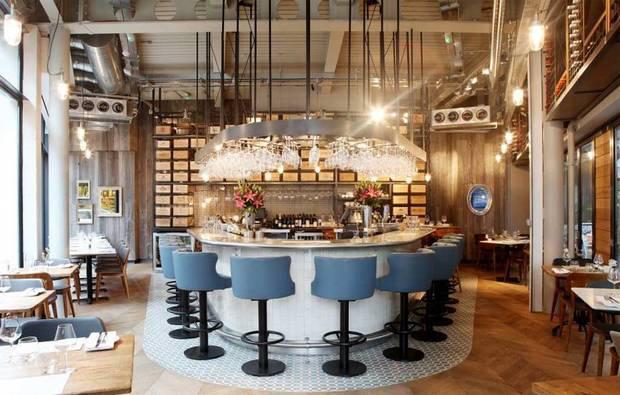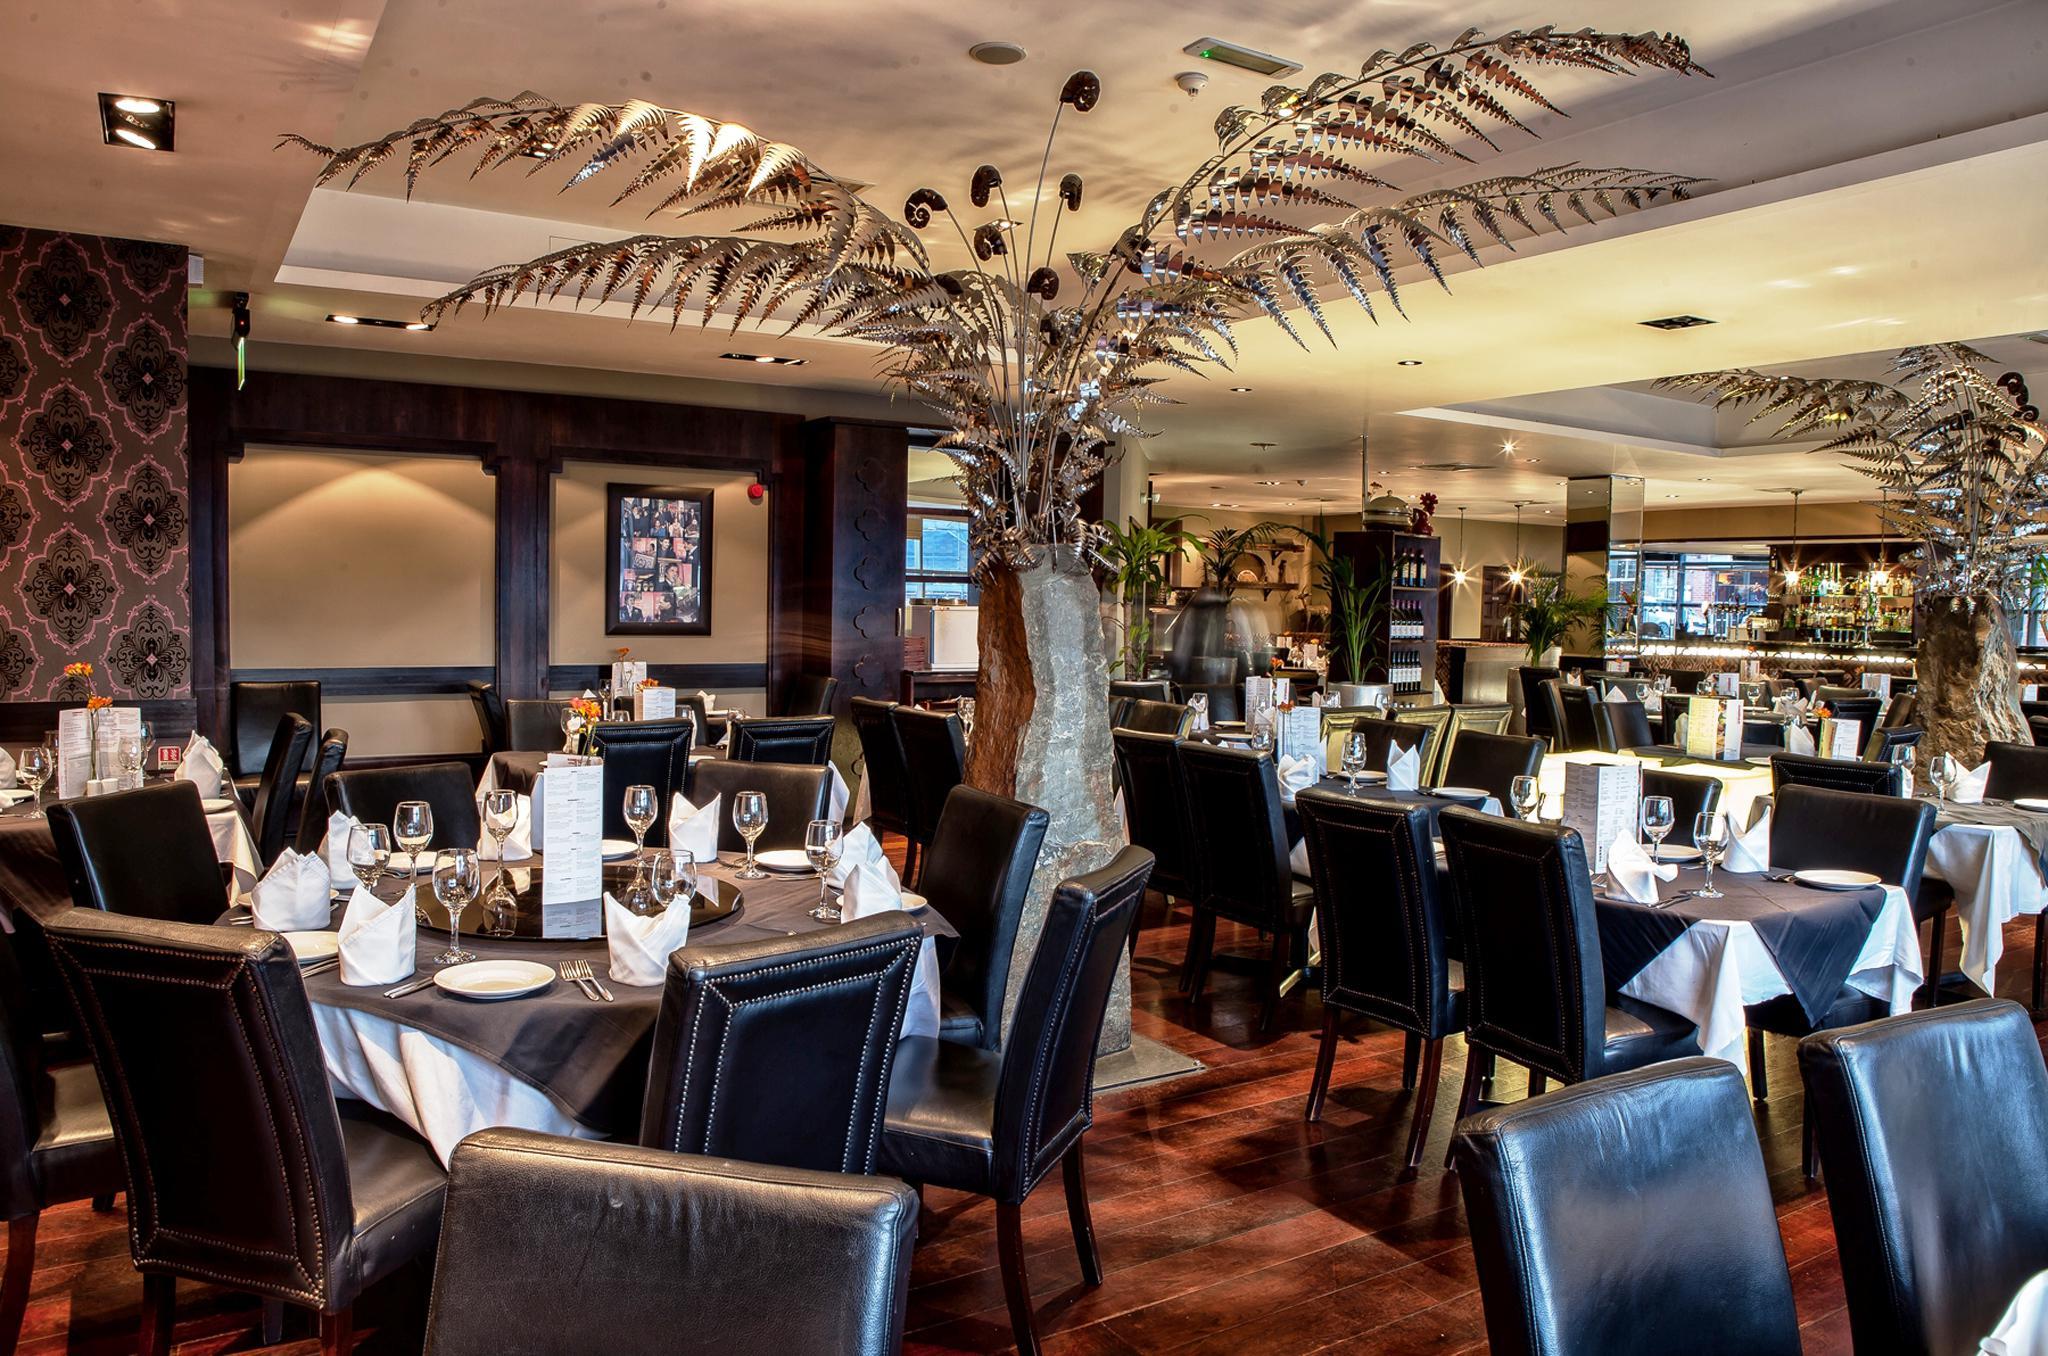The first image is the image on the left, the second image is the image on the right. Given the left and right images, does the statement "One image shows an interior with a black column in the center, dome-shaped suspended lights, and paned square windows in the ceiling." hold true? Answer yes or no. No. 